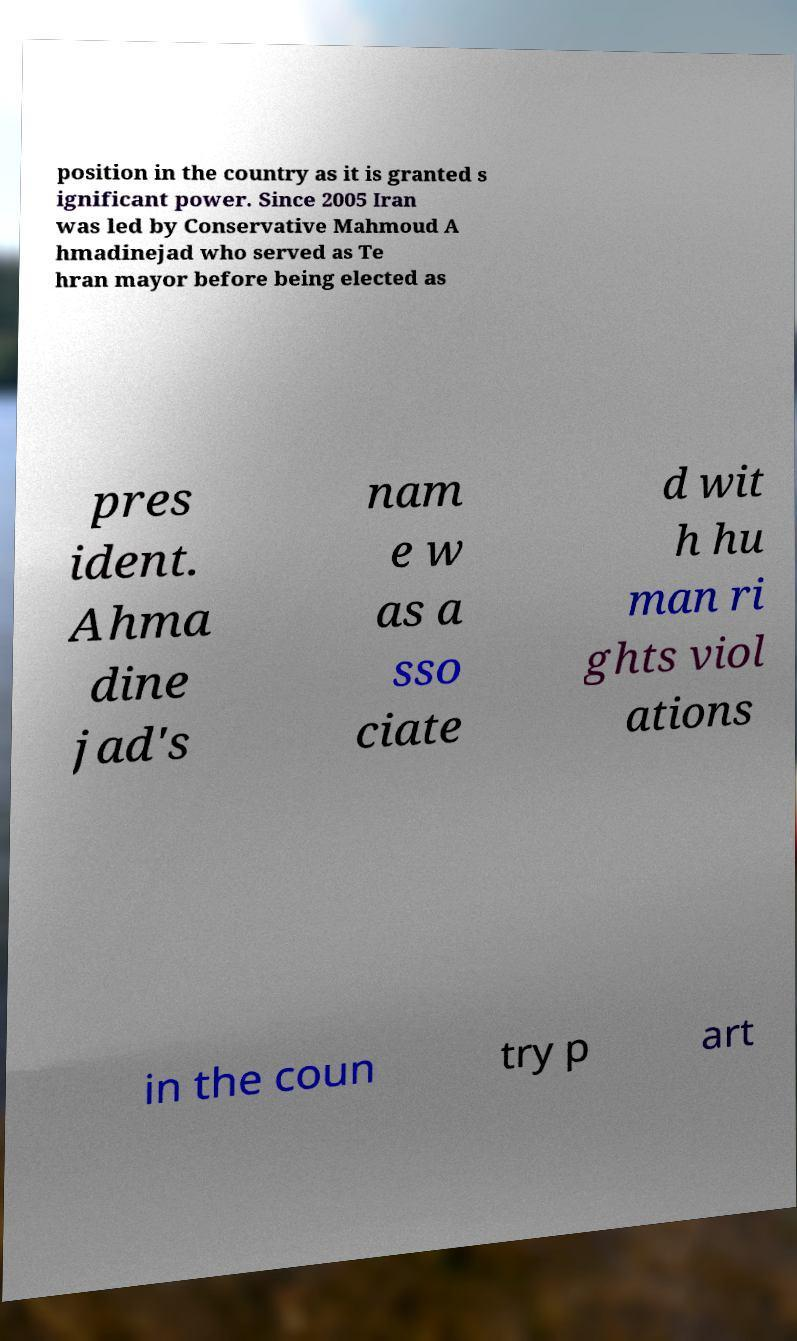Could you assist in decoding the text presented in this image and type it out clearly? position in the country as it is granted s ignificant power. Since 2005 Iran was led by Conservative Mahmoud A hmadinejad who served as Te hran mayor before being elected as pres ident. Ahma dine jad's nam e w as a sso ciate d wit h hu man ri ghts viol ations in the coun try p art 